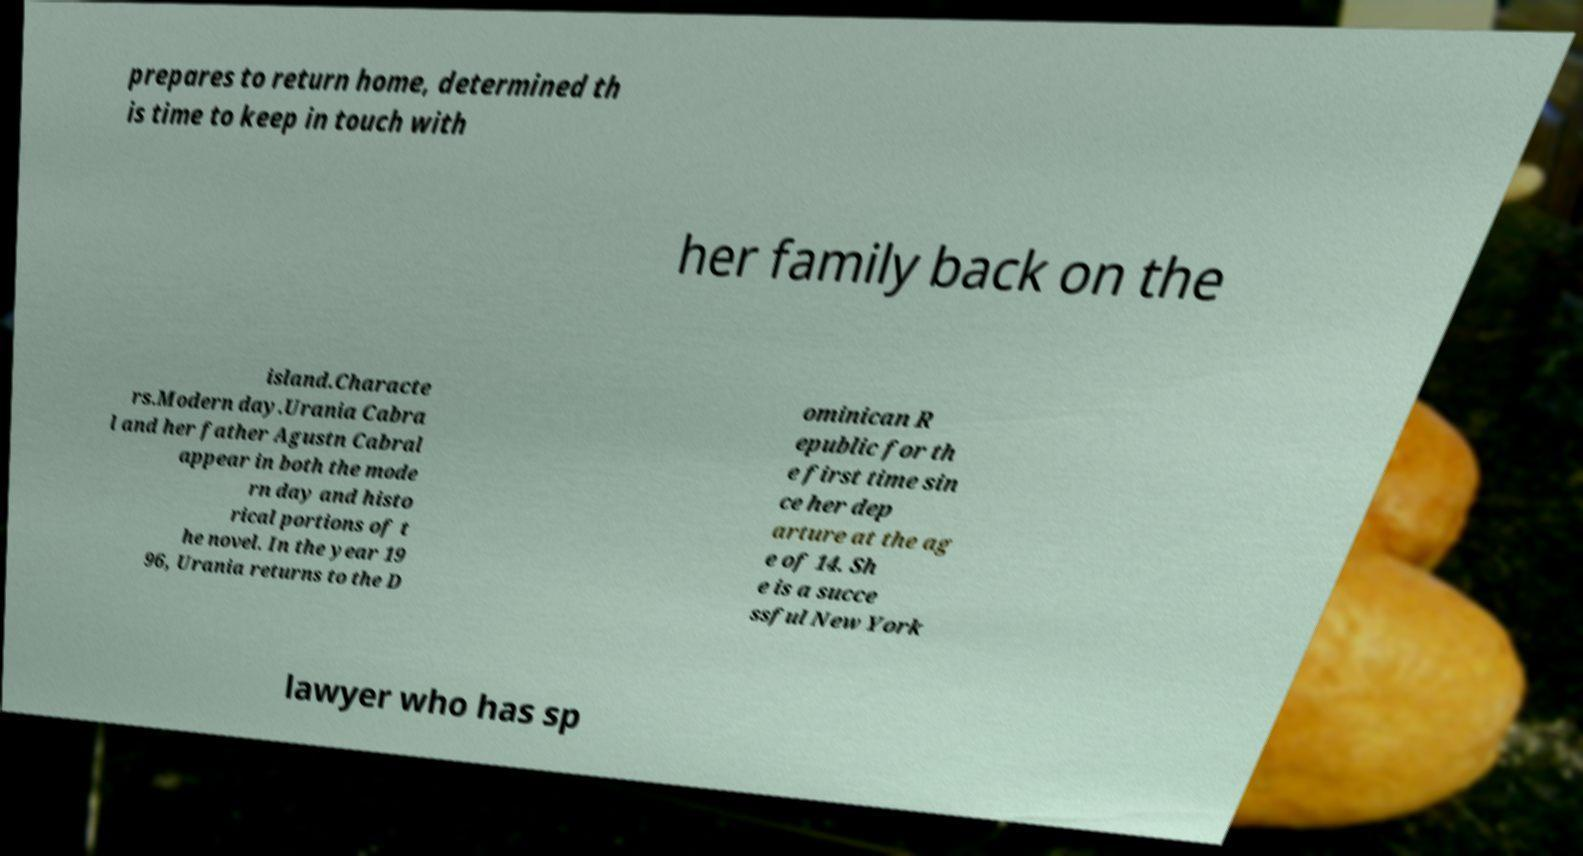Can you read and provide the text displayed in the image?This photo seems to have some interesting text. Can you extract and type it out for me? prepares to return home, determined th is time to keep in touch with her family back on the island.Characte rs.Modern day.Urania Cabra l and her father Agustn Cabral appear in both the mode rn day and histo rical portions of t he novel. In the year 19 96, Urania returns to the D ominican R epublic for th e first time sin ce her dep arture at the ag e of 14. Sh e is a succe ssful New York lawyer who has sp 